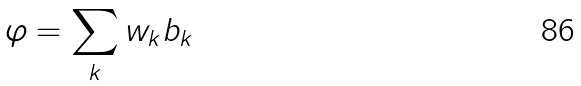Convert formula to latex. <formula><loc_0><loc_0><loc_500><loc_500>\varphi = \sum _ { k } w _ { k } b _ { k }</formula> 